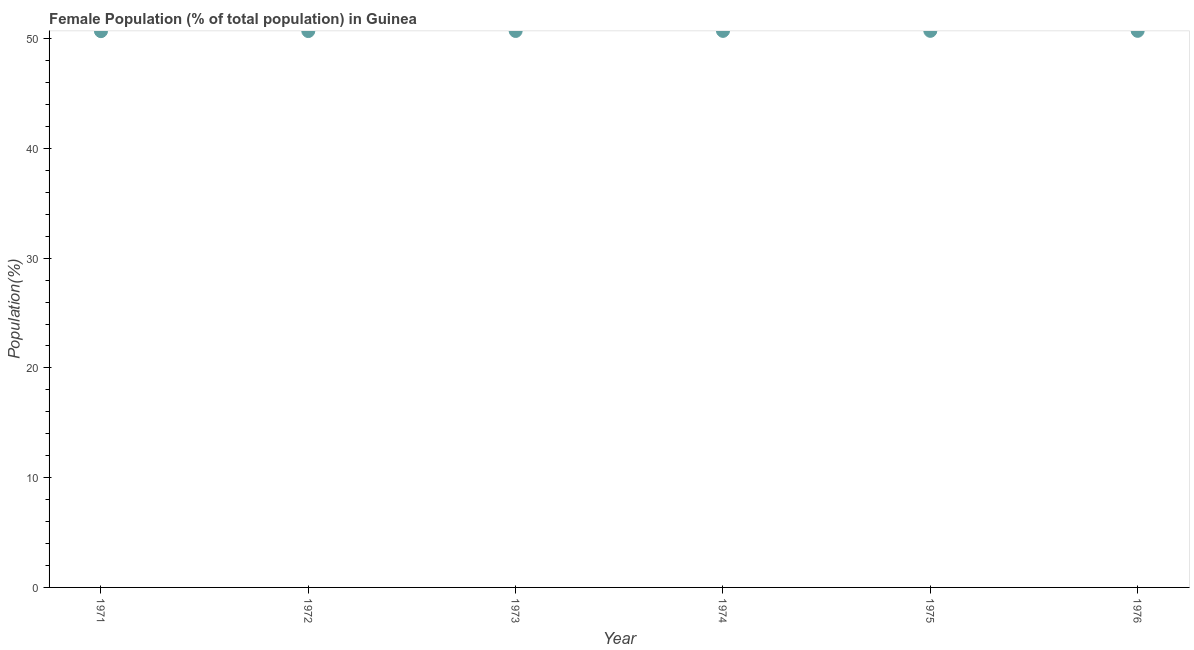What is the female population in 1971?
Give a very brief answer. 50.69. Across all years, what is the maximum female population?
Ensure brevity in your answer.  50.72. Across all years, what is the minimum female population?
Keep it short and to the point. 50.69. In which year was the female population maximum?
Make the answer very short. 1976. In which year was the female population minimum?
Ensure brevity in your answer.  1971. What is the sum of the female population?
Your answer should be very brief. 304.24. What is the difference between the female population in 1972 and 1976?
Offer a very short reply. -0.02. What is the average female population per year?
Your response must be concise. 50.71. What is the median female population?
Provide a succinct answer. 50.71. Do a majority of the years between 1975 and 1973 (inclusive) have female population greater than 38 %?
Keep it short and to the point. No. What is the ratio of the female population in 1972 to that in 1976?
Your answer should be very brief. 1. Is the female population in 1973 less than that in 1975?
Ensure brevity in your answer.  Yes. Is the difference between the female population in 1971 and 1973 greater than the difference between any two years?
Keep it short and to the point. No. What is the difference between the highest and the second highest female population?
Provide a short and direct response. 0. What is the difference between the highest and the lowest female population?
Offer a terse response. 0.03. In how many years, is the female population greater than the average female population taken over all years?
Make the answer very short. 3. Does the female population monotonically increase over the years?
Ensure brevity in your answer.  Yes. How many dotlines are there?
Your answer should be compact. 1. Are the values on the major ticks of Y-axis written in scientific E-notation?
Offer a terse response. No. Does the graph contain any zero values?
Offer a terse response. No. Does the graph contain grids?
Your response must be concise. No. What is the title of the graph?
Keep it short and to the point. Female Population (% of total population) in Guinea. What is the label or title of the Y-axis?
Your answer should be compact. Population(%). What is the Population(%) in 1971?
Keep it short and to the point. 50.69. What is the Population(%) in 1972?
Provide a short and direct response. 50.7. What is the Population(%) in 1973?
Your response must be concise. 50.71. What is the Population(%) in 1974?
Offer a terse response. 50.71. What is the Population(%) in 1975?
Your answer should be very brief. 50.72. What is the Population(%) in 1976?
Keep it short and to the point. 50.72. What is the difference between the Population(%) in 1971 and 1972?
Offer a very short reply. -0.01. What is the difference between the Population(%) in 1971 and 1973?
Keep it short and to the point. -0.02. What is the difference between the Population(%) in 1971 and 1974?
Ensure brevity in your answer.  -0.03. What is the difference between the Population(%) in 1971 and 1975?
Your answer should be very brief. -0.03. What is the difference between the Population(%) in 1971 and 1976?
Provide a succinct answer. -0.03. What is the difference between the Population(%) in 1972 and 1973?
Give a very brief answer. -0.01. What is the difference between the Population(%) in 1972 and 1974?
Provide a short and direct response. -0.02. What is the difference between the Population(%) in 1972 and 1975?
Ensure brevity in your answer.  -0.02. What is the difference between the Population(%) in 1972 and 1976?
Your answer should be compact. -0.02. What is the difference between the Population(%) in 1973 and 1974?
Your answer should be very brief. -0.01. What is the difference between the Population(%) in 1973 and 1975?
Provide a succinct answer. -0.01. What is the difference between the Population(%) in 1973 and 1976?
Provide a short and direct response. -0.01. What is the difference between the Population(%) in 1974 and 1975?
Offer a very short reply. -0. What is the difference between the Population(%) in 1974 and 1976?
Keep it short and to the point. -0. What is the difference between the Population(%) in 1975 and 1976?
Your answer should be very brief. -0. What is the ratio of the Population(%) in 1971 to that in 1972?
Provide a short and direct response. 1. What is the ratio of the Population(%) in 1971 to that in 1975?
Ensure brevity in your answer.  1. What is the ratio of the Population(%) in 1972 to that in 1973?
Provide a short and direct response. 1. What is the ratio of the Population(%) in 1972 to that in 1974?
Provide a short and direct response. 1. What is the ratio of the Population(%) in 1972 to that in 1975?
Ensure brevity in your answer.  1. What is the ratio of the Population(%) in 1973 to that in 1974?
Offer a very short reply. 1. What is the ratio of the Population(%) in 1975 to that in 1976?
Make the answer very short. 1. 